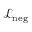Convert formula to latex. <formula><loc_0><loc_0><loc_500><loc_500>\mathcal { L } _ { n e g }</formula> 